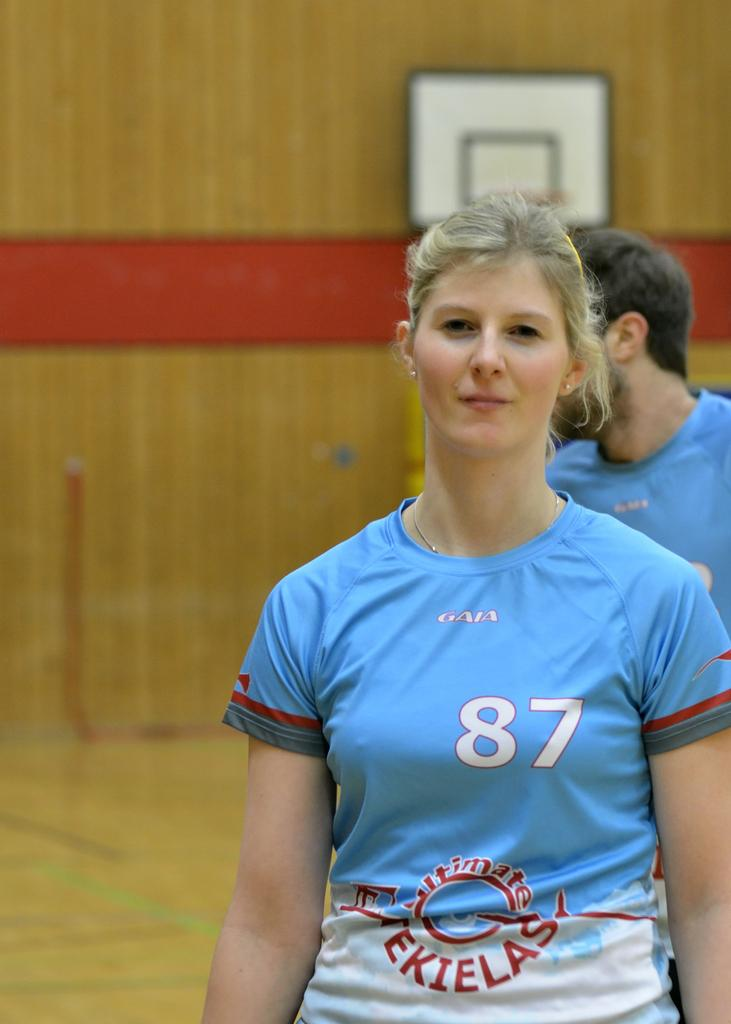What is the main subject of the image? There is a woman standing in the middle of the image. What is the woman doing in the image? The woman is smiling. Can you describe the person behind the woman? There is a person behind the woman, but their appearance or actions are not specified in the facts. What can be seen in the background of the image? There is a wall visible in the background. What type of calculator is the woman using in the image? There is no calculator present in the image. How many pigs are visible in the image? There are no pigs visible in the image. 